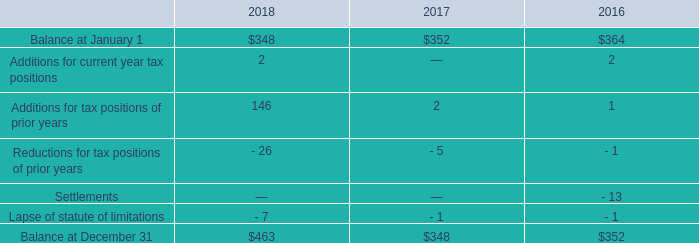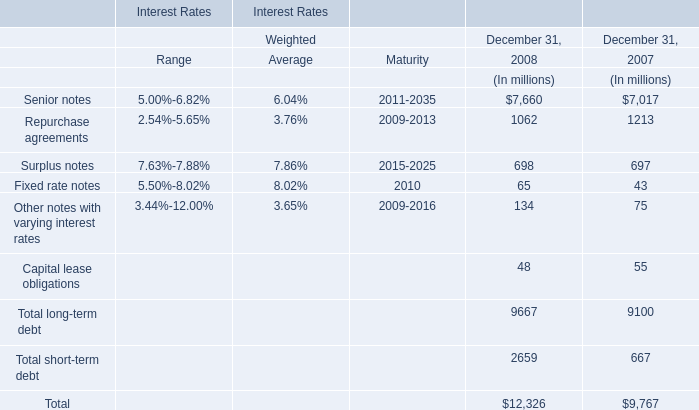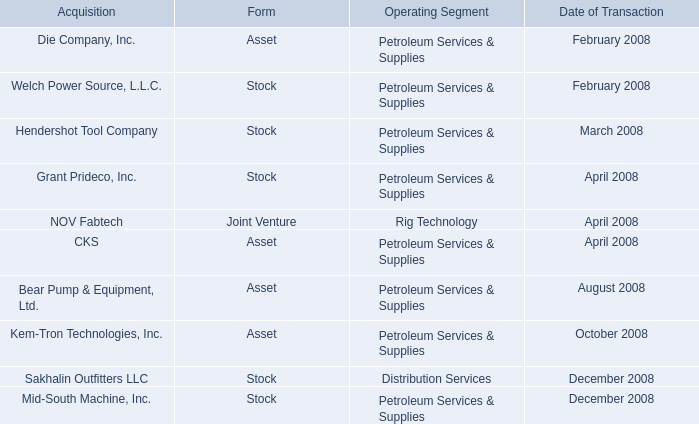What is the increasing rate of Total short-term debt between 2007 and 2008? 
Computations: ((2659 - 667) / 667)
Answer: 2.98651. 